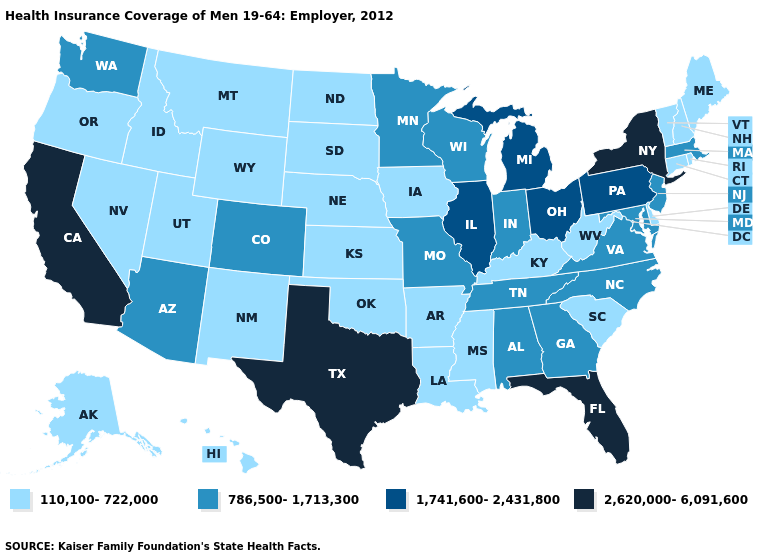What is the highest value in the South ?
Short answer required. 2,620,000-6,091,600. Name the states that have a value in the range 1,741,600-2,431,800?
Be succinct. Illinois, Michigan, Ohio, Pennsylvania. What is the value of Iowa?
Write a very short answer. 110,100-722,000. Does the map have missing data?
Be succinct. No. Is the legend a continuous bar?
Answer briefly. No. What is the lowest value in the USA?
Quick response, please. 110,100-722,000. Does Ohio have the lowest value in the MidWest?
Answer briefly. No. Name the states that have a value in the range 110,100-722,000?
Concise answer only. Alaska, Arkansas, Connecticut, Delaware, Hawaii, Idaho, Iowa, Kansas, Kentucky, Louisiana, Maine, Mississippi, Montana, Nebraska, Nevada, New Hampshire, New Mexico, North Dakota, Oklahoma, Oregon, Rhode Island, South Carolina, South Dakota, Utah, Vermont, West Virginia, Wyoming. What is the value of South Carolina?
Give a very brief answer. 110,100-722,000. What is the value of New Jersey?
Be succinct. 786,500-1,713,300. What is the highest value in states that border New York?
Answer briefly. 1,741,600-2,431,800. Name the states that have a value in the range 2,620,000-6,091,600?
Keep it brief. California, Florida, New York, Texas. Name the states that have a value in the range 2,620,000-6,091,600?
Keep it brief. California, Florida, New York, Texas. What is the lowest value in the South?
Be succinct. 110,100-722,000. What is the lowest value in the MidWest?
Concise answer only. 110,100-722,000. 